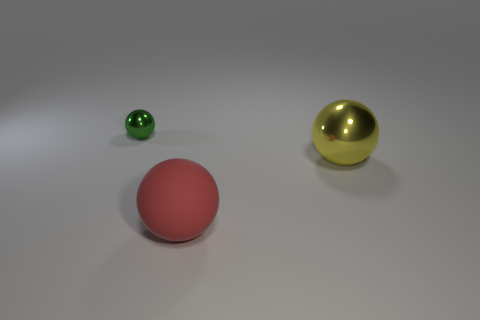There is a shiny thing to the right of the green thing; is it the same shape as the shiny object that is to the left of the red rubber ball?
Your answer should be compact. Yes. There is a small green object that is the same shape as the yellow metal object; what material is it?
Your answer should be compact. Metal. The object on the left side of the red matte thing has what shape?
Provide a succinct answer. Sphere. There is a large sphere that is in front of the object on the right side of the sphere in front of the yellow object; what color is it?
Make the answer very short. Red. The large thing that is the same material as the small thing is what shape?
Provide a short and direct response. Sphere. Are there fewer tiny purple shiny spheres than balls?
Ensure brevity in your answer.  Yes. Does the green object have the same material as the yellow ball?
Your answer should be very brief. Yes. What number of other objects are there of the same color as the small shiny sphere?
Provide a succinct answer. 0. Is the number of large brown rubber objects greater than the number of big metal spheres?
Keep it short and to the point. No. Does the red matte object have the same size as the shiny thing that is to the right of the matte sphere?
Offer a terse response. Yes. 